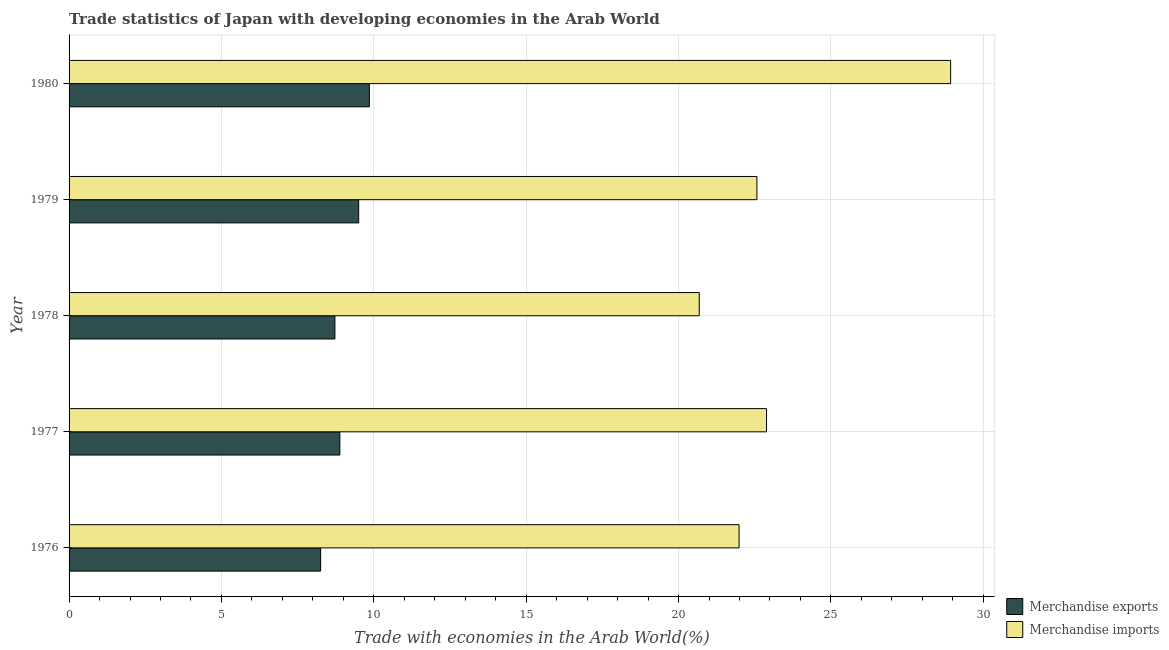How many different coloured bars are there?
Offer a very short reply. 2. How many bars are there on the 5th tick from the bottom?
Your answer should be compact. 2. What is the label of the 3rd group of bars from the top?
Offer a terse response. 1978. What is the merchandise exports in 1978?
Ensure brevity in your answer.  8.72. Across all years, what is the maximum merchandise imports?
Offer a very short reply. 28.93. Across all years, what is the minimum merchandise imports?
Provide a succinct answer. 20.68. In which year was the merchandise imports minimum?
Provide a short and direct response. 1978. What is the total merchandise imports in the graph?
Give a very brief answer. 117.05. What is the difference between the merchandise imports in 1978 and that in 1979?
Your answer should be very brief. -1.89. What is the difference between the merchandise imports in 1976 and the merchandise exports in 1977?
Provide a succinct answer. 13.1. What is the average merchandise exports per year?
Make the answer very short. 9.04. In the year 1980, what is the difference between the merchandise imports and merchandise exports?
Your answer should be compact. 19.07. In how many years, is the merchandise exports greater than 12 %?
Your answer should be very brief. 0. What is the ratio of the merchandise exports in 1977 to that in 1979?
Your answer should be very brief. 0.94. Is the difference between the merchandise imports in 1978 and 1980 greater than the difference between the merchandise exports in 1978 and 1980?
Provide a succinct answer. No. What is the difference between the highest and the second highest merchandise imports?
Ensure brevity in your answer.  6.04. What is the difference between the highest and the lowest merchandise exports?
Make the answer very short. 1.6. In how many years, is the merchandise imports greater than the average merchandise imports taken over all years?
Ensure brevity in your answer.  1. What does the 2nd bar from the top in 1980 represents?
Provide a short and direct response. Merchandise exports. How many bars are there?
Keep it short and to the point. 10. Are all the bars in the graph horizontal?
Your response must be concise. Yes. Does the graph contain any zero values?
Ensure brevity in your answer.  No. Does the graph contain grids?
Keep it short and to the point. Yes. Where does the legend appear in the graph?
Ensure brevity in your answer.  Bottom right. How many legend labels are there?
Your answer should be compact. 2. How are the legend labels stacked?
Keep it short and to the point. Vertical. What is the title of the graph?
Offer a very short reply. Trade statistics of Japan with developing economies in the Arab World. What is the label or title of the X-axis?
Provide a succinct answer. Trade with economies in the Arab World(%). What is the label or title of the Y-axis?
Your answer should be compact. Year. What is the Trade with economies in the Arab World(%) of Merchandise exports in 1976?
Your response must be concise. 8.26. What is the Trade with economies in the Arab World(%) in Merchandise imports in 1976?
Offer a very short reply. 21.99. What is the Trade with economies in the Arab World(%) of Merchandise exports in 1977?
Give a very brief answer. 8.89. What is the Trade with economies in the Arab World(%) of Merchandise imports in 1977?
Provide a short and direct response. 22.89. What is the Trade with economies in the Arab World(%) of Merchandise exports in 1978?
Ensure brevity in your answer.  8.72. What is the Trade with economies in the Arab World(%) of Merchandise imports in 1978?
Offer a terse response. 20.68. What is the Trade with economies in the Arab World(%) of Merchandise exports in 1979?
Provide a succinct answer. 9.5. What is the Trade with economies in the Arab World(%) in Merchandise imports in 1979?
Offer a terse response. 22.57. What is the Trade with economies in the Arab World(%) of Merchandise exports in 1980?
Your response must be concise. 9.85. What is the Trade with economies in the Arab World(%) in Merchandise imports in 1980?
Provide a succinct answer. 28.93. Across all years, what is the maximum Trade with economies in the Arab World(%) of Merchandise exports?
Make the answer very short. 9.85. Across all years, what is the maximum Trade with economies in the Arab World(%) of Merchandise imports?
Your answer should be very brief. 28.93. Across all years, what is the minimum Trade with economies in the Arab World(%) in Merchandise exports?
Make the answer very short. 8.26. Across all years, what is the minimum Trade with economies in the Arab World(%) in Merchandise imports?
Your response must be concise. 20.68. What is the total Trade with economies in the Arab World(%) of Merchandise exports in the graph?
Keep it short and to the point. 45.22. What is the total Trade with economies in the Arab World(%) of Merchandise imports in the graph?
Your answer should be compact. 117.05. What is the difference between the Trade with economies in the Arab World(%) of Merchandise exports in 1976 and that in 1977?
Ensure brevity in your answer.  -0.63. What is the difference between the Trade with economies in the Arab World(%) of Merchandise imports in 1976 and that in 1977?
Your answer should be very brief. -0.9. What is the difference between the Trade with economies in the Arab World(%) of Merchandise exports in 1976 and that in 1978?
Ensure brevity in your answer.  -0.47. What is the difference between the Trade with economies in the Arab World(%) of Merchandise imports in 1976 and that in 1978?
Your answer should be compact. 1.31. What is the difference between the Trade with economies in the Arab World(%) in Merchandise exports in 1976 and that in 1979?
Offer a very short reply. -1.25. What is the difference between the Trade with economies in the Arab World(%) in Merchandise imports in 1976 and that in 1979?
Keep it short and to the point. -0.59. What is the difference between the Trade with economies in the Arab World(%) of Merchandise exports in 1976 and that in 1980?
Your response must be concise. -1.6. What is the difference between the Trade with economies in the Arab World(%) in Merchandise imports in 1976 and that in 1980?
Ensure brevity in your answer.  -6.94. What is the difference between the Trade with economies in the Arab World(%) of Merchandise exports in 1977 and that in 1978?
Make the answer very short. 0.16. What is the difference between the Trade with economies in the Arab World(%) in Merchandise imports in 1977 and that in 1978?
Your answer should be very brief. 2.21. What is the difference between the Trade with economies in the Arab World(%) in Merchandise exports in 1977 and that in 1979?
Ensure brevity in your answer.  -0.62. What is the difference between the Trade with economies in the Arab World(%) of Merchandise imports in 1977 and that in 1979?
Your answer should be compact. 0.32. What is the difference between the Trade with economies in the Arab World(%) of Merchandise exports in 1977 and that in 1980?
Offer a very short reply. -0.97. What is the difference between the Trade with economies in the Arab World(%) in Merchandise imports in 1977 and that in 1980?
Your answer should be very brief. -6.04. What is the difference between the Trade with economies in the Arab World(%) of Merchandise exports in 1978 and that in 1979?
Make the answer very short. -0.78. What is the difference between the Trade with economies in the Arab World(%) of Merchandise imports in 1978 and that in 1979?
Ensure brevity in your answer.  -1.89. What is the difference between the Trade with economies in the Arab World(%) in Merchandise exports in 1978 and that in 1980?
Make the answer very short. -1.13. What is the difference between the Trade with economies in the Arab World(%) of Merchandise imports in 1978 and that in 1980?
Offer a terse response. -8.25. What is the difference between the Trade with economies in the Arab World(%) of Merchandise exports in 1979 and that in 1980?
Make the answer very short. -0.35. What is the difference between the Trade with economies in the Arab World(%) of Merchandise imports in 1979 and that in 1980?
Provide a short and direct response. -6.36. What is the difference between the Trade with economies in the Arab World(%) of Merchandise exports in 1976 and the Trade with economies in the Arab World(%) of Merchandise imports in 1977?
Give a very brief answer. -14.63. What is the difference between the Trade with economies in the Arab World(%) of Merchandise exports in 1976 and the Trade with economies in the Arab World(%) of Merchandise imports in 1978?
Your answer should be compact. -12.42. What is the difference between the Trade with economies in the Arab World(%) of Merchandise exports in 1976 and the Trade with economies in the Arab World(%) of Merchandise imports in 1979?
Provide a succinct answer. -14.32. What is the difference between the Trade with economies in the Arab World(%) of Merchandise exports in 1976 and the Trade with economies in the Arab World(%) of Merchandise imports in 1980?
Make the answer very short. -20.67. What is the difference between the Trade with economies in the Arab World(%) in Merchandise exports in 1977 and the Trade with economies in the Arab World(%) in Merchandise imports in 1978?
Give a very brief answer. -11.79. What is the difference between the Trade with economies in the Arab World(%) of Merchandise exports in 1977 and the Trade with economies in the Arab World(%) of Merchandise imports in 1979?
Your answer should be compact. -13.69. What is the difference between the Trade with economies in the Arab World(%) of Merchandise exports in 1977 and the Trade with economies in the Arab World(%) of Merchandise imports in 1980?
Give a very brief answer. -20.04. What is the difference between the Trade with economies in the Arab World(%) of Merchandise exports in 1978 and the Trade with economies in the Arab World(%) of Merchandise imports in 1979?
Ensure brevity in your answer.  -13.85. What is the difference between the Trade with economies in the Arab World(%) in Merchandise exports in 1978 and the Trade with economies in the Arab World(%) in Merchandise imports in 1980?
Make the answer very short. -20.21. What is the difference between the Trade with economies in the Arab World(%) of Merchandise exports in 1979 and the Trade with economies in the Arab World(%) of Merchandise imports in 1980?
Make the answer very short. -19.42. What is the average Trade with economies in the Arab World(%) in Merchandise exports per year?
Give a very brief answer. 9.04. What is the average Trade with economies in the Arab World(%) in Merchandise imports per year?
Give a very brief answer. 23.41. In the year 1976, what is the difference between the Trade with economies in the Arab World(%) of Merchandise exports and Trade with economies in the Arab World(%) of Merchandise imports?
Your answer should be compact. -13.73. In the year 1977, what is the difference between the Trade with economies in the Arab World(%) of Merchandise exports and Trade with economies in the Arab World(%) of Merchandise imports?
Give a very brief answer. -14. In the year 1978, what is the difference between the Trade with economies in the Arab World(%) in Merchandise exports and Trade with economies in the Arab World(%) in Merchandise imports?
Give a very brief answer. -11.96. In the year 1979, what is the difference between the Trade with economies in the Arab World(%) of Merchandise exports and Trade with economies in the Arab World(%) of Merchandise imports?
Offer a terse response. -13.07. In the year 1980, what is the difference between the Trade with economies in the Arab World(%) of Merchandise exports and Trade with economies in the Arab World(%) of Merchandise imports?
Make the answer very short. -19.07. What is the ratio of the Trade with economies in the Arab World(%) in Merchandise exports in 1976 to that in 1977?
Ensure brevity in your answer.  0.93. What is the ratio of the Trade with economies in the Arab World(%) of Merchandise imports in 1976 to that in 1977?
Your answer should be compact. 0.96. What is the ratio of the Trade with economies in the Arab World(%) in Merchandise exports in 1976 to that in 1978?
Provide a succinct answer. 0.95. What is the ratio of the Trade with economies in the Arab World(%) of Merchandise imports in 1976 to that in 1978?
Provide a short and direct response. 1.06. What is the ratio of the Trade with economies in the Arab World(%) in Merchandise exports in 1976 to that in 1979?
Provide a short and direct response. 0.87. What is the ratio of the Trade with economies in the Arab World(%) in Merchandise imports in 1976 to that in 1979?
Offer a terse response. 0.97. What is the ratio of the Trade with economies in the Arab World(%) in Merchandise exports in 1976 to that in 1980?
Offer a terse response. 0.84. What is the ratio of the Trade with economies in the Arab World(%) in Merchandise imports in 1976 to that in 1980?
Your answer should be very brief. 0.76. What is the ratio of the Trade with economies in the Arab World(%) in Merchandise exports in 1977 to that in 1978?
Give a very brief answer. 1.02. What is the ratio of the Trade with economies in the Arab World(%) of Merchandise imports in 1977 to that in 1978?
Your answer should be compact. 1.11. What is the ratio of the Trade with economies in the Arab World(%) of Merchandise exports in 1977 to that in 1979?
Your answer should be very brief. 0.94. What is the ratio of the Trade with economies in the Arab World(%) of Merchandise imports in 1977 to that in 1979?
Make the answer very short. 1.01. What is the ratio of the Trade with economies in the Arab World(%) in Merchandise exports in 1977 to that in 1980?
Offer a very short reply. 0.9. What is the ratio of the Trade with economies in the Arab World(%) in Merchandise imports in 1977 to that in 1980?
Provide a short and direct response. 0.79. What is the ratio of the Trade with economies in the Arab World(%) in Merchandise exports in 1978 to that in 1979?
Keep it short and to the point. 0.92. What is the ratio of the Trade with economies in the Arab World(%) in Merchandise imports in 1978 to that in 1979?
Ensure brevity in your answer.  0.92. What is the ratio of the Trade with economies in the Arab World(%) of Merchandise exports in 1978 to that in 1980?
Make the answer very short. 0.89. What is the ratio of the Trade with economies in the Arab World(%) in Merchandise imports in 1978 to that in 1980?
Your answer should be compact. 0.71. What is the ratio of the Trade with economies in the Arab World(%) of Merchandise exports in 1979 to that in 1980?
Give a very brief answer. 0.96. What is the ratio of the Trade with economies in the Arab World(%) in Merchandise imports in 1979 to that in 1980?
Provide a short and direct response. 0.78. What is the difference between the highest and the second highest Trade with economies in the Arab World(%) of Merchandise exports?
Ensure brevity in your answer.  0.35. What is the difference between the highest and the second highest Trade with economies in the Arab World(%) of Merchandise imports?
Give a very brief answer. 6.04. What is the difference between the highest and the lowest Trade with economies in the Arab World(%) in Merchandise exports?
Keep it short and to the point. 1.6. What is the difference between the highest and the lowest Trade with economies in the Arab World(%) in Merchandise imports?
Provide a succinct answer. 8.25. 